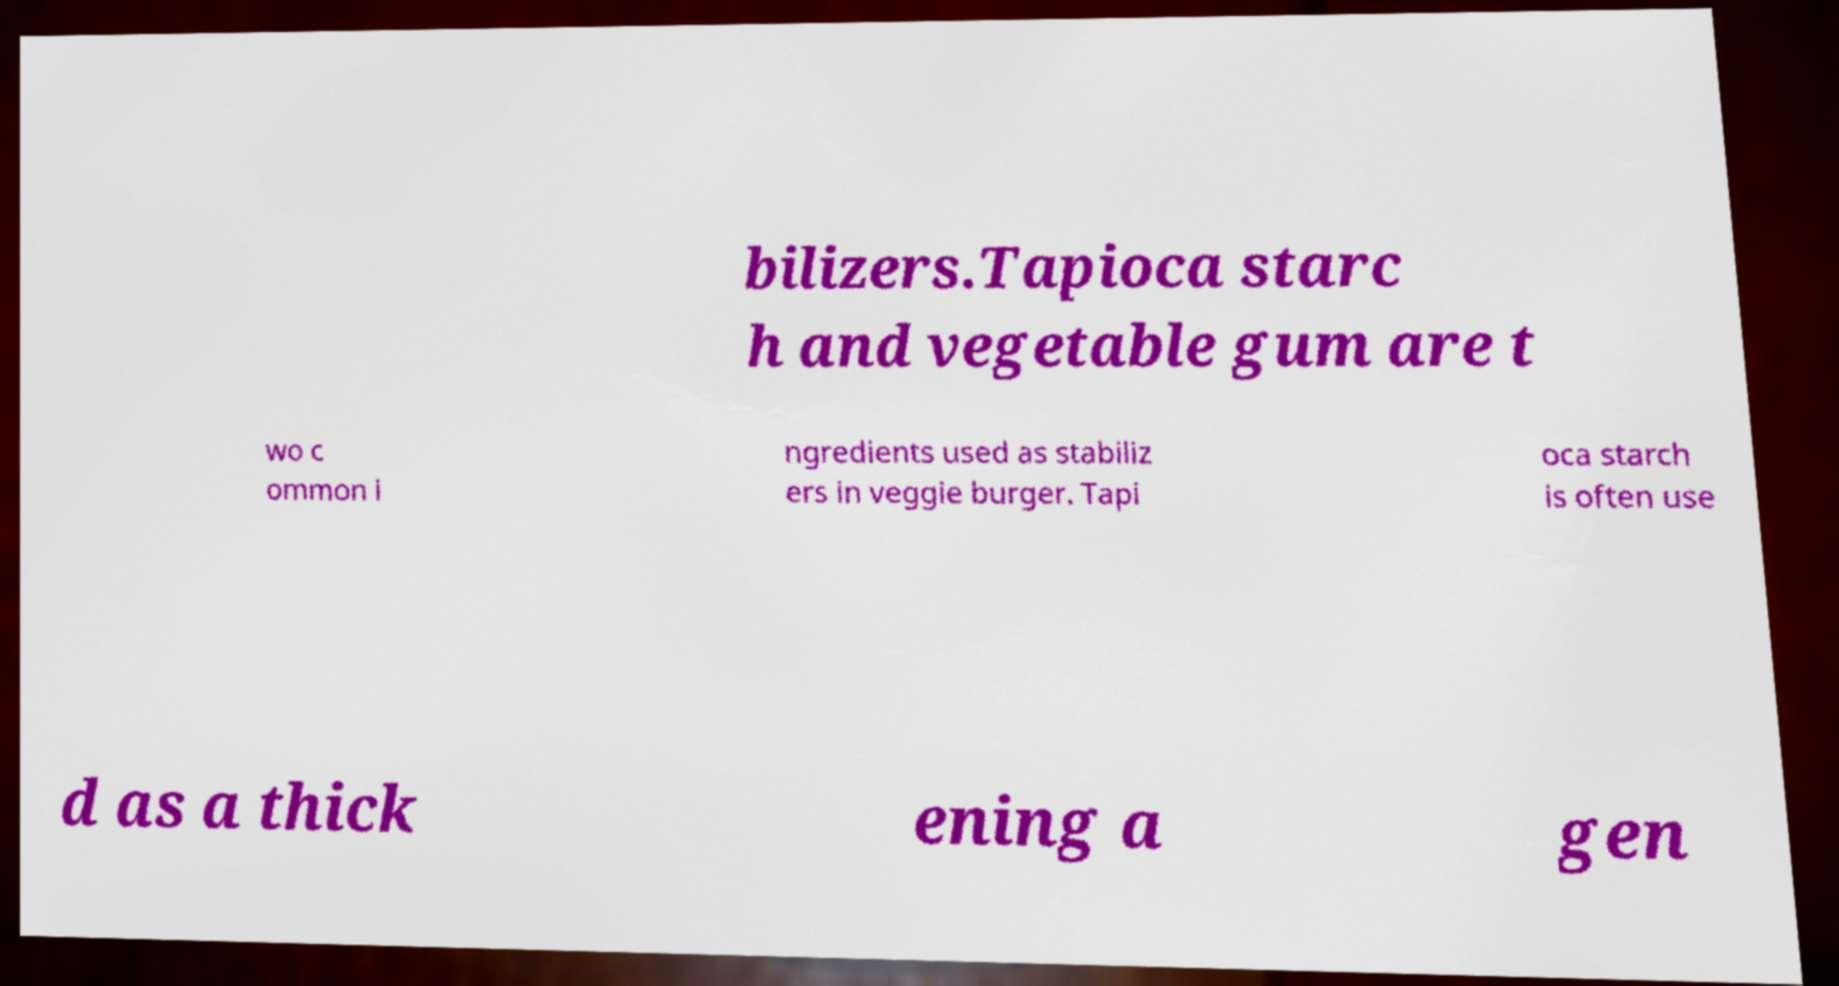I need the written content from this picture converted into text. Can you do that? bilizers.Tapioca starc h and vegetable gum are t wo c ommon i ngredients used as stabiliz ers in veggie burger. Tapi oca starch is often use d as a thick ening a gen 